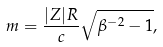<formula> <loc_0><loc_0><loc_500><loc_500>m = \frac { | Z | R } { c } \sqrt { \beta ^ { - 2 } - 1 } ,</formula> 